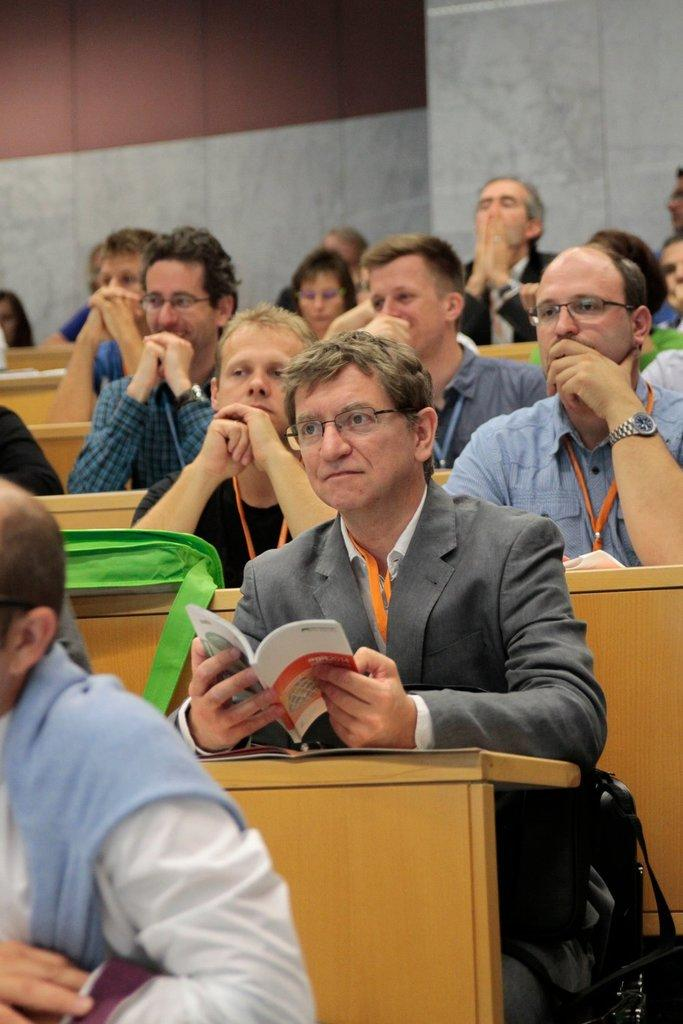What is happening in the image? There is a group of people in the image, and they are sitting. What are the people doing while sitting? The people are reading a book. How many oranges are being used as bookmarks in the image? There are no oranges present in the image. What type of pen is being used to write notes in the book? There is no pen visible in the image, as the people are only reading the book. 